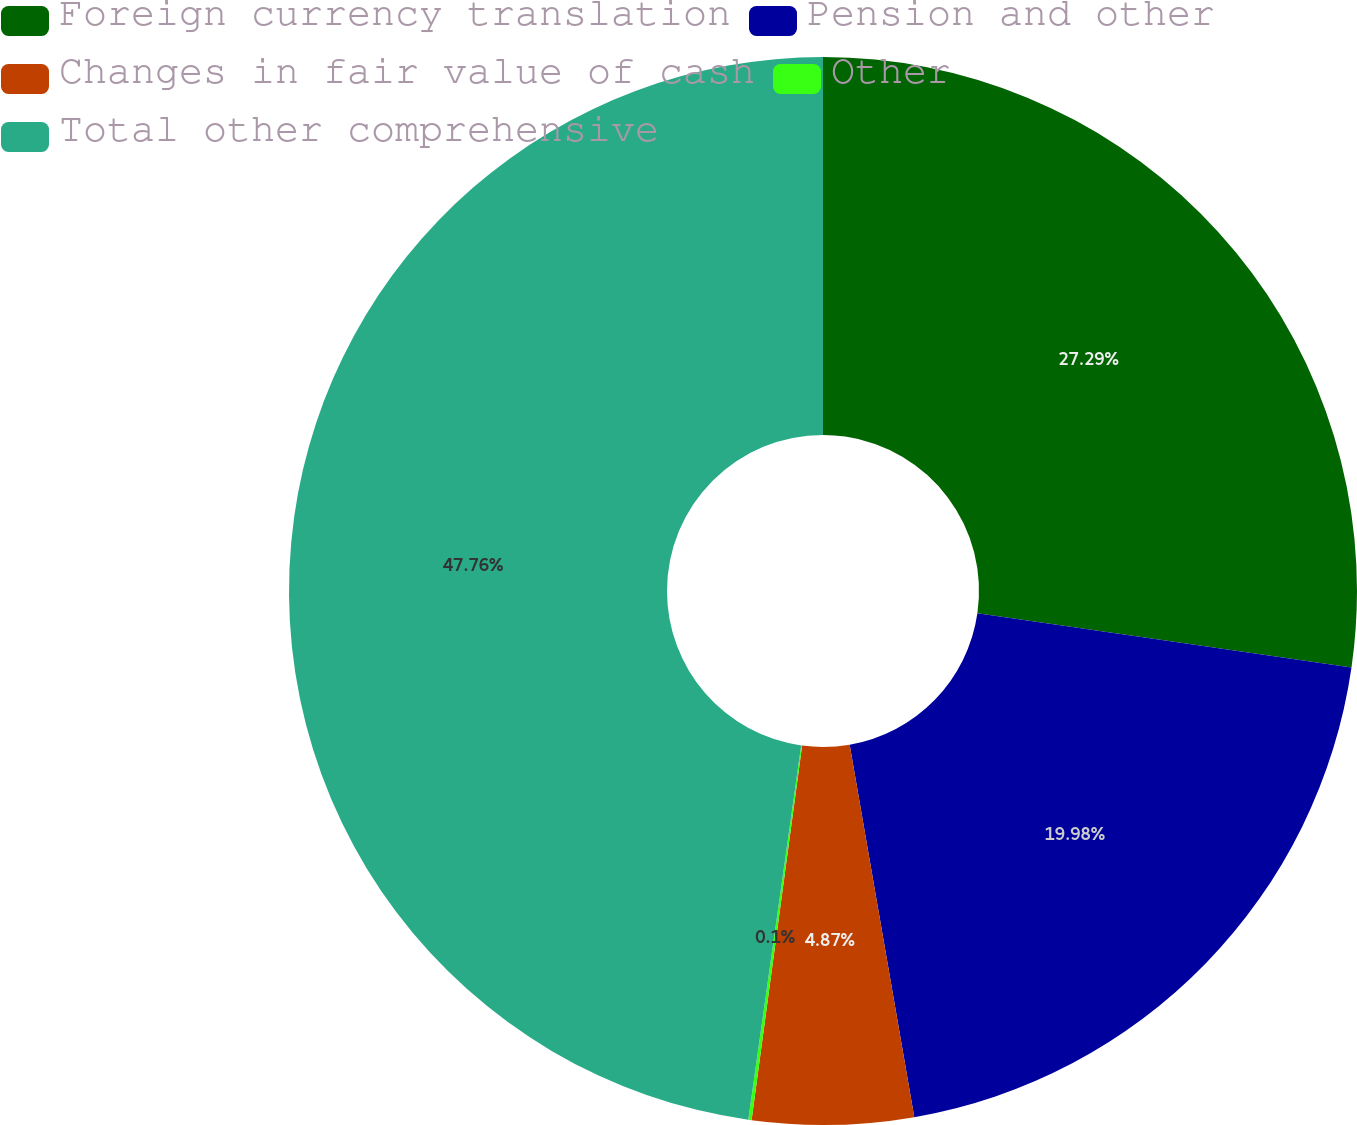Convert chart to OTSL. <chart><loc_0><loc_0><loc_500><loc_500><pie_chart><fcel>Foreign currency translation<fcel>Pension and other<fcel>Changes in fair value of cash<fcel>Other<fcel>Total other comprehensive<nl><fcel>27.29%<fcel>19.98%<fcel>4.87%<fcel>0.1%<fcel>47.77%<nl></chart> 